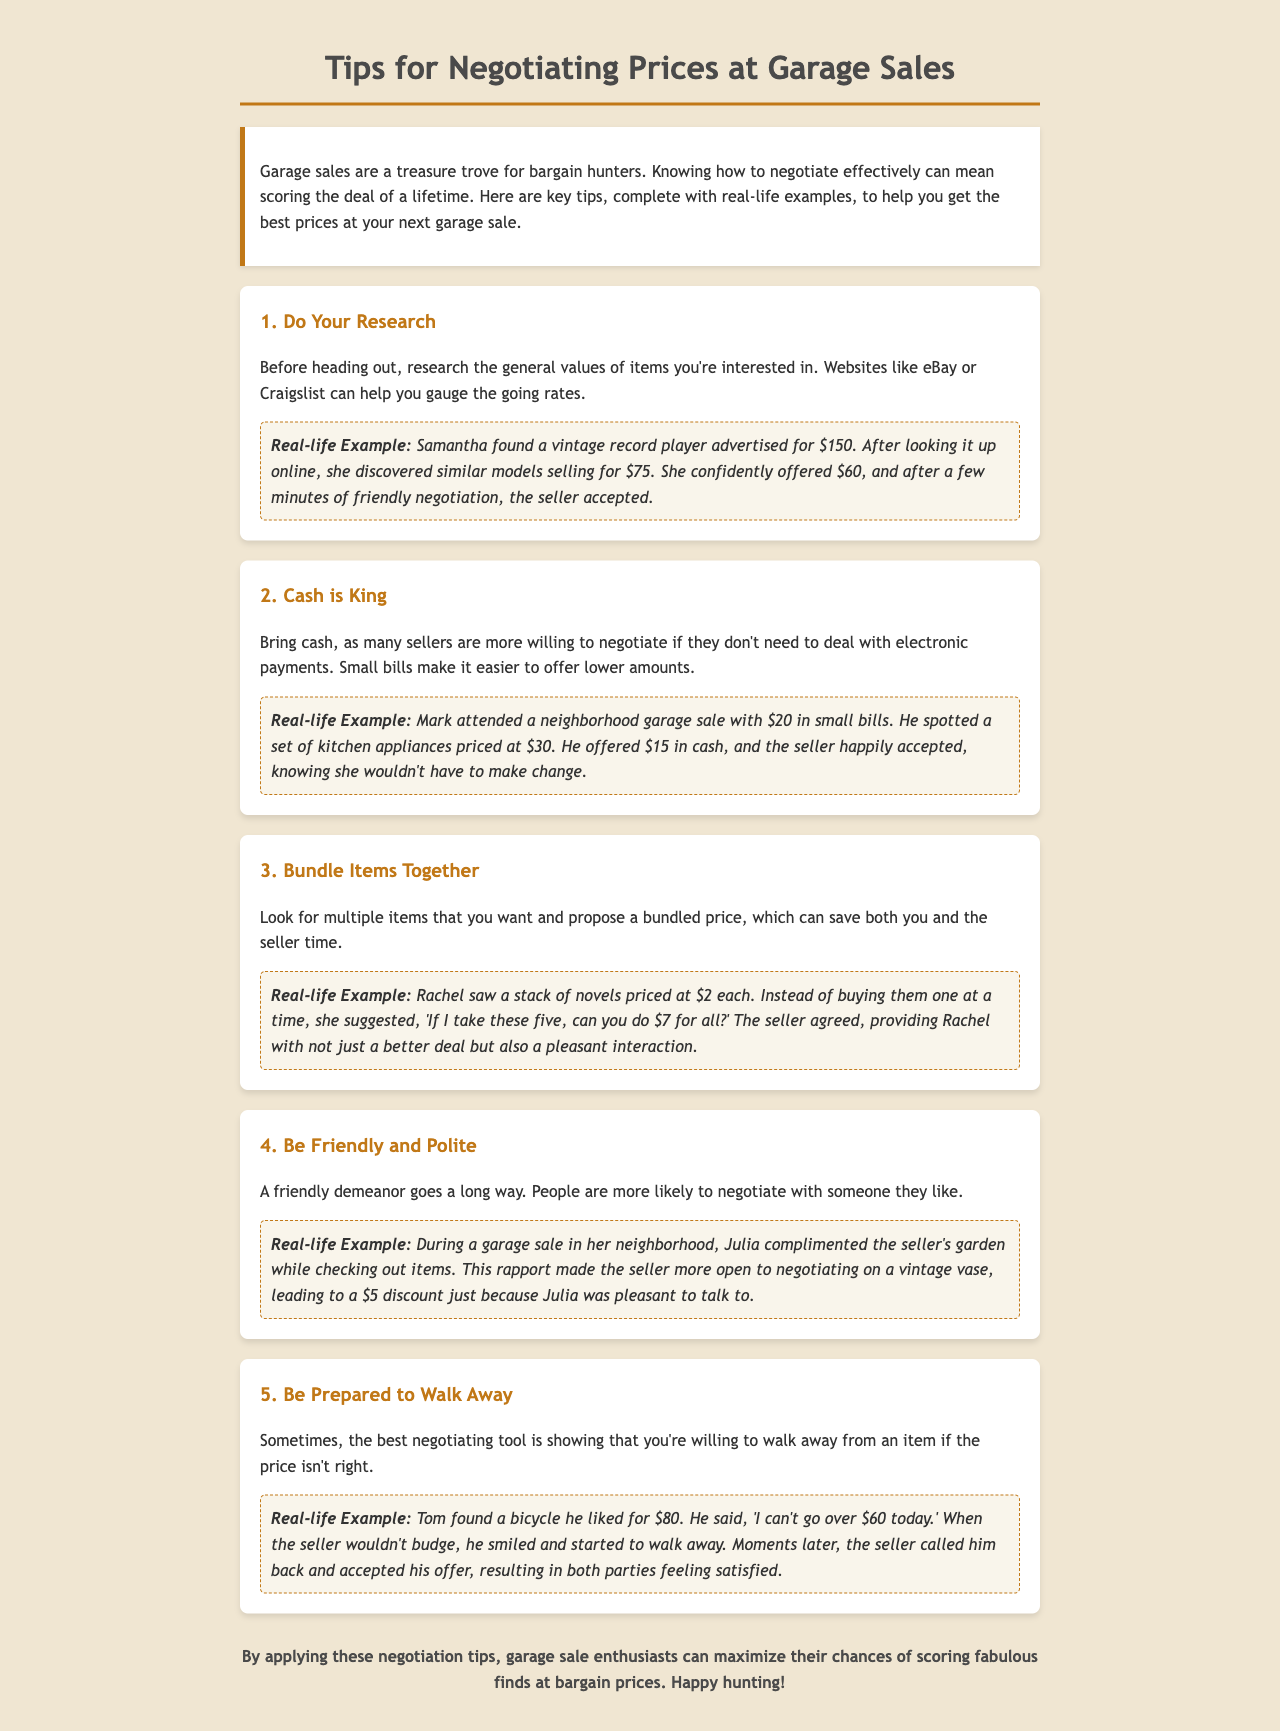What is the title of the document? The title can be found at the top of the document and is indicated as "Tips for Negotiating Prices at Garage Sales."
Answer: Tips for Negotiating Prices at Garage Sales How many tips are provided in the document? Counting the sections in the document, there are five distinct tips listed for negotiation.
Answer: 5 What was the original price of the vintage record player Samantha found? The document states that the vintage record player was originally advertised for $150 before negotiation.
Answer: $150 What was the agreed price for the bundle of novels suggested by Rachel? Rachel proposed a bundled price of $7 for the five novels she wanted to purchase.
Answer: $7 What is one way to improve negotiation chances according to the document? The document emphasizes being friendly and polite as a way to enhance negotiation success.
Answer: Friendly and polite What item did Tom negotiate the price for? Tom negotiated the price for a bicycle he wanted to buy at the garage sale.
Answer: Bicycle What impact does bringing cash have on negotiations? The document suggests that bringing cash makes sellers more willing to negotiate since they avoid dealing with electronic payments.
Answer: Increased willingness to negotiate How did Julia's compliment influence her negotiation? Julia's friendly compliment about the seller's garden fostered a pleasant interaction, making the seller more agreeable to negotiate.
Answer: Fostered pleasant interaction 